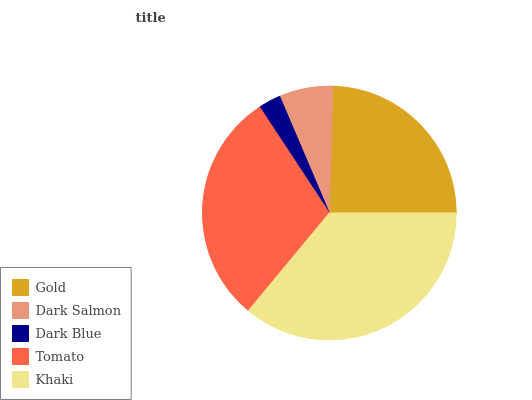Is Dark Blue the minimum?
Answer yes or no. Yes. Is Khaki the maximum?
Answer yes or no. Yes. Is Dark Salmon the minimum?
Answer yes or no. No. Is Dark Salmon the maximum?
Answer yes or no. No. Is Gold greater than Dark Salmon?
Answer yes or no. Yes. Is Dark Salmon less than Gold?
Answer yes or no. Yes. Is Dark Salmon greater than Gold?
Answer yes or no. No. Is Gold less than Dark Salmon?
Answer yes or no. No. Is Gold the high median?
Answer yes or no. Yes. Is Gold the low median?
Answer yes or no. Yes. Is Dark Salmon the high median?
Answer yes or no. No. Is Tomato the low median?
Answer yes or no. No. 